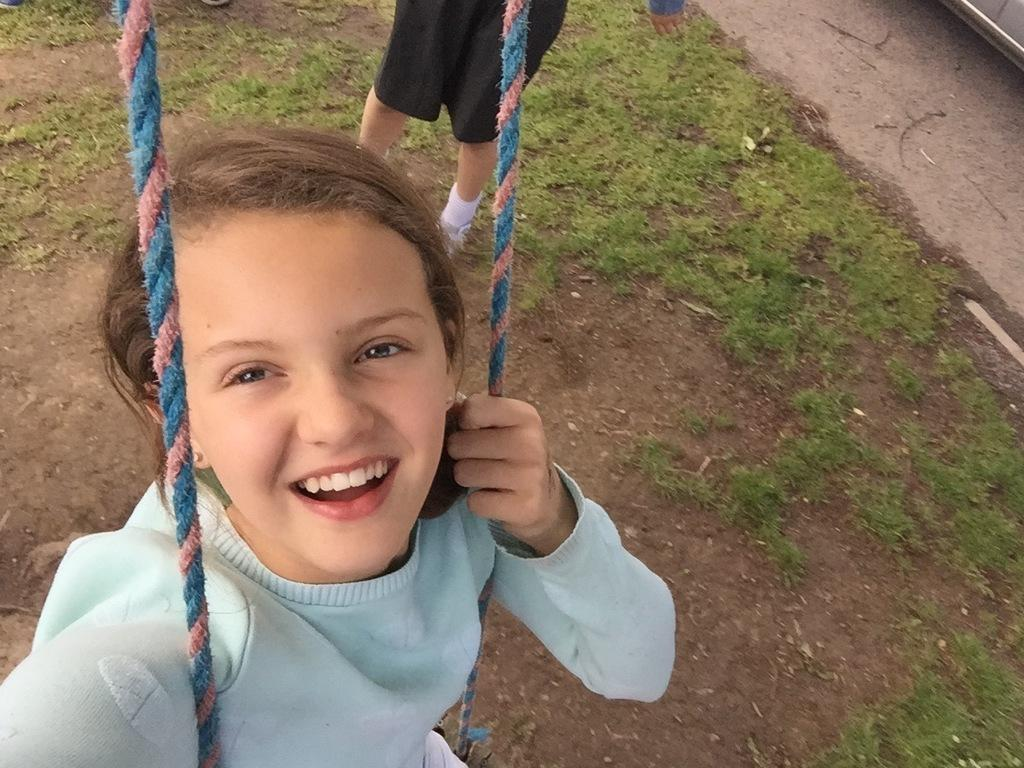Who is present in the image? There is a girl and another person in the image. What is the setting of the image? The image features soil and grass at the bottom. What type of loaf is the girl holding in the image? There is no loaf present in the image. Can you provide an example of the girl's facial expression in the image? The provided facts do not include information about the girl's facial expression, so it cannot be described. 